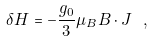<formula> <loc_0><loc_0><loc_500><loc_500>\delta H = - \frac { g _ { 0 } } { 3 } \mu _ { B } B \cdot J \ ,</formula> 